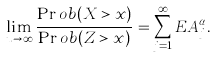<formula> <loc_0><loc_0><loc_500><loc_500>\lim _ { u \to \infty } \frac { \Pr o b ( X > x ) } { \Pr o b ( Z > x ) } = \sum _ { j = 1 } ^ { \infty } E A _ { j } ^ { \alpha } .</formula> 